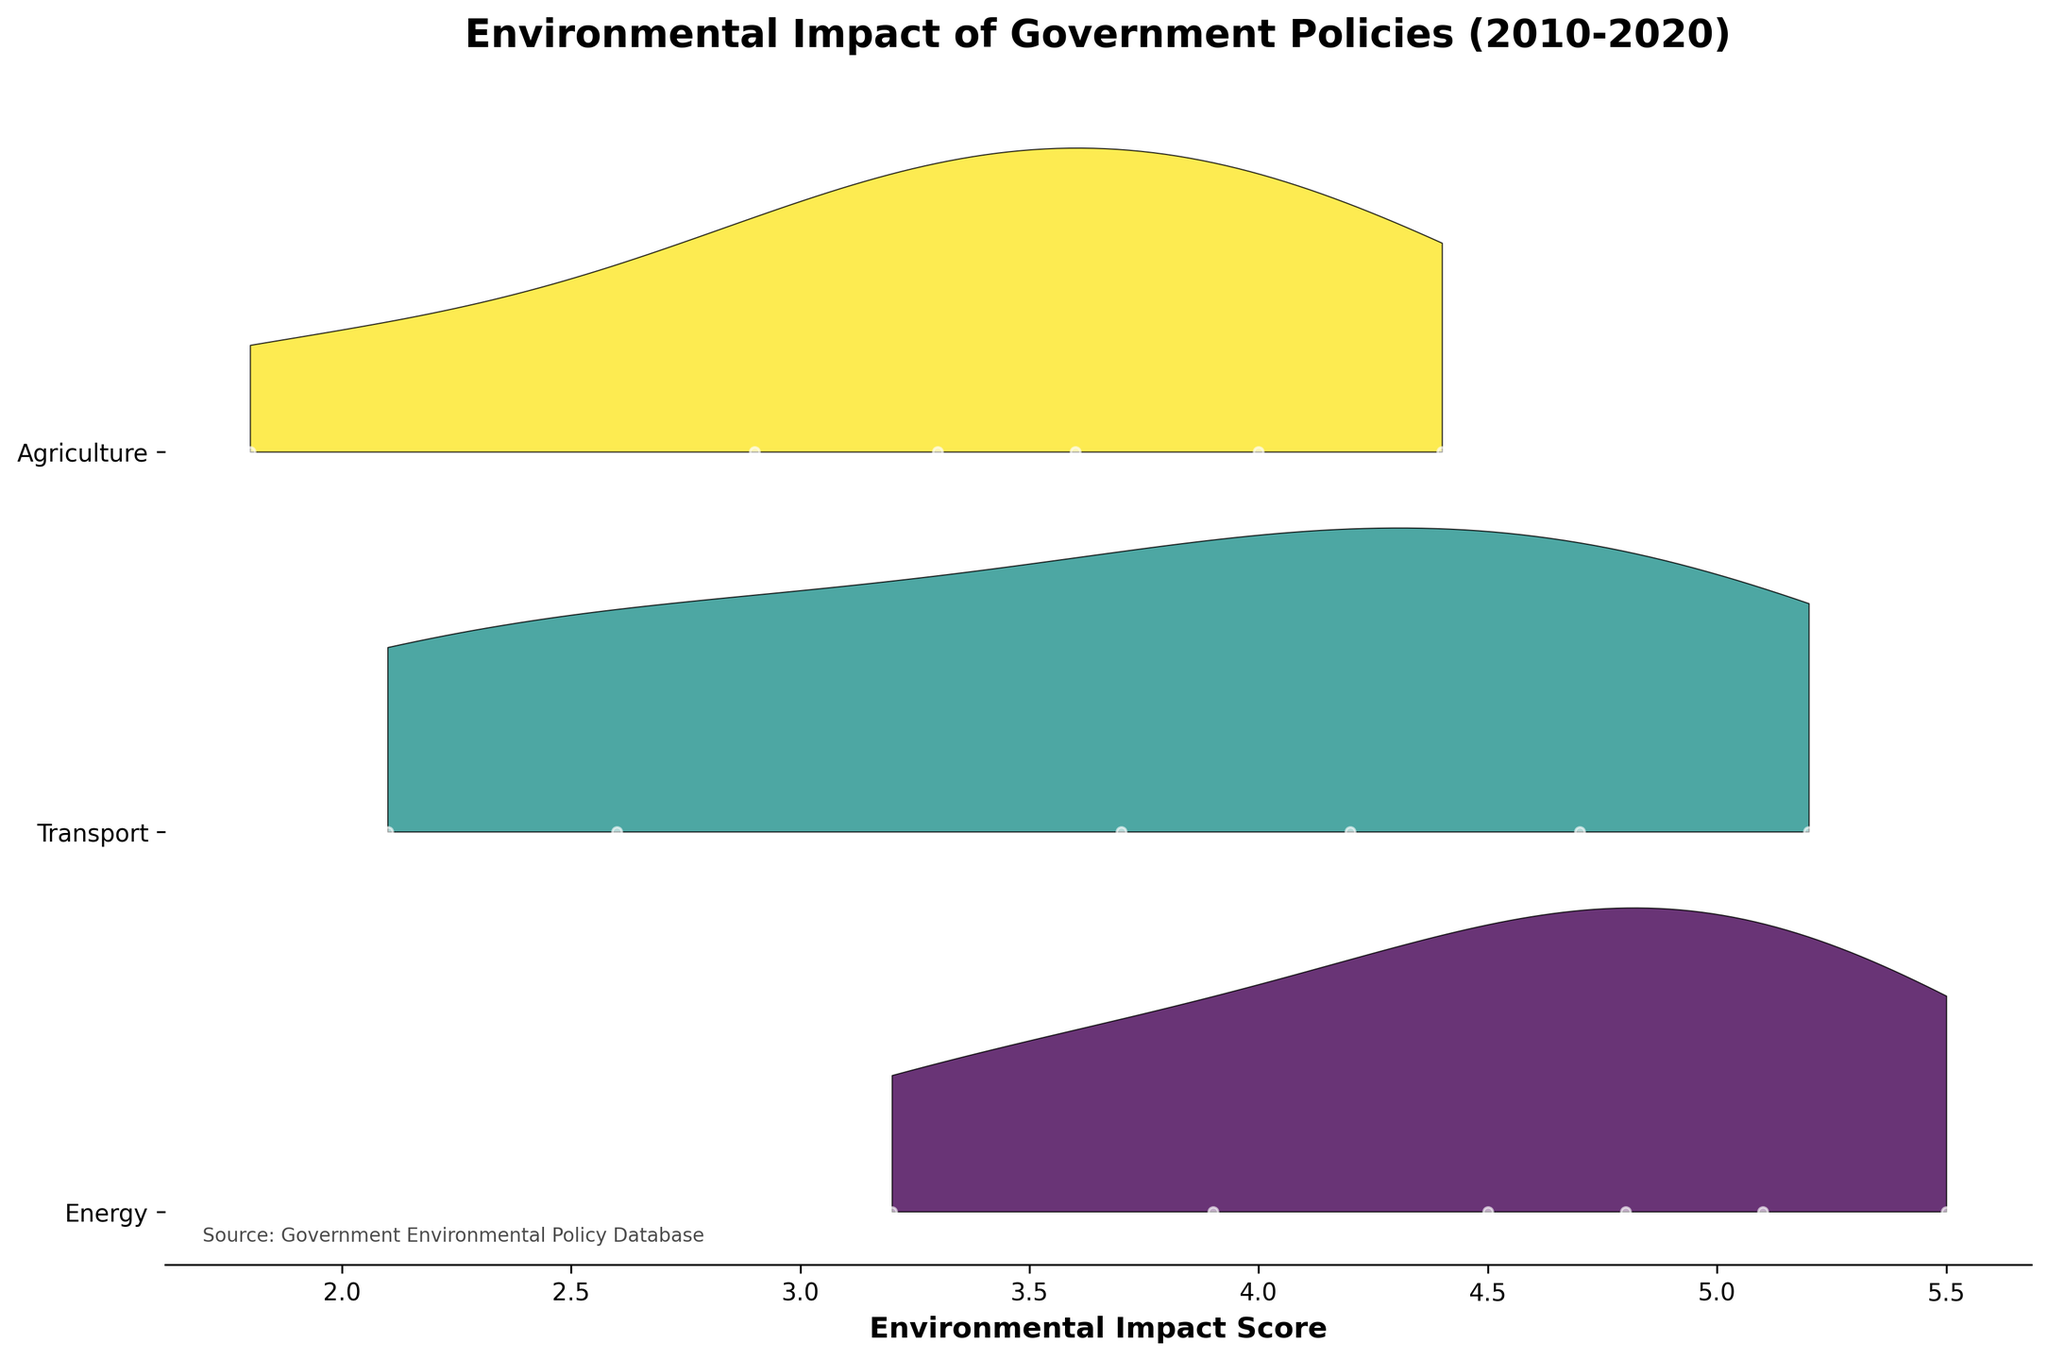Which sector has the highest environmental impact score in 2020? By observing the ridgeline plot, for the year 2020, the highest peak is within the range of 5 to 5.5. The sector labeled with this peak is Energy.
Answer: Energy What is the title of the figure? The title is displayed at the top center of the figure, often in a slightly larger and bold font for emphasis.
Answer: Environmental Impact of Government Policies (2010-2020) Which year had the lowest environmental impact score for agriculture policies? By analyzing the ridgeline curves for the agriculture sector across different years, the lowest peak is in the 2010 curve, near the score of 1.8.
Answer: 2010 How do the peaks of the transport sector policies compare between 2012 and 2020? The ridgeline plot shows that in 2012, the peak of the environmental impact score for transport sector policies is around 3.7, whereas in 2020, the peak is higher, around 5.2. This shows an increase over the years.
Answer: Higher in 2020 Which sector had the greatest variance in environmental impact scores across the years depicted? By observing the spread and shapes of each sector's ridgeline curves, the Energy sector shows the widest range of scores, with peaks scattered from 3.2 to 5.5 across different years.
Answer: Energy What is the environmental impact score of the Public Transit Expansion policy? By locating the year 2012 and identifying the specific policy name within the transport sector curve, the score can be observed approximately at 3.7.
Answer: 3.7 Which years are represented for each sector in the ridgeline plot? By examining the y-axis which marks the years and observing the alignment with each sector's ridgeline, it's apparent that all sectors show data for 2010, 2012, 2014, 2016, 2018, and 2020.
Answer: 2010, 2012, 2014, 2016, 2018, 2020 How does the environmental impact of the Electric Vehicle Subsidy policy in 2010 compare to the Low Emission Zone Implementation in 2016? By locating the years 2010 and 2016 on the y-axis and comparing the impact scores within the Transport sector, Electric Vehicle Subsidy in 2010 is around 2.1 whereas Low Emission Zone Implementation in 2016 is around 4.2 indicating a significant increase in impact score.
Answer: Higher in 2016 What is the range of environmental impact scores for Smart Grid Development policy? Looking at the ridgeline curve for the year 2018 specific to the Energy sector, the peak for Smart Grid Development policy is prominently within the top range, marked around 5.1.
Answer: 5.1 How does the environmental impact of Sustainable Farming Initiative in 2010 compare to Vertical Farming Initiative in 2020? By finding the relevant years for the Agriculture sector, Sustainable Farming Initiative in 2010 has a score of about 1.8, while Vertical Farming Initiative in 2020 has a score approximately 4.4, indicating a significant increase in environmental impact score over the decade.
Answer: Higher in 2020 